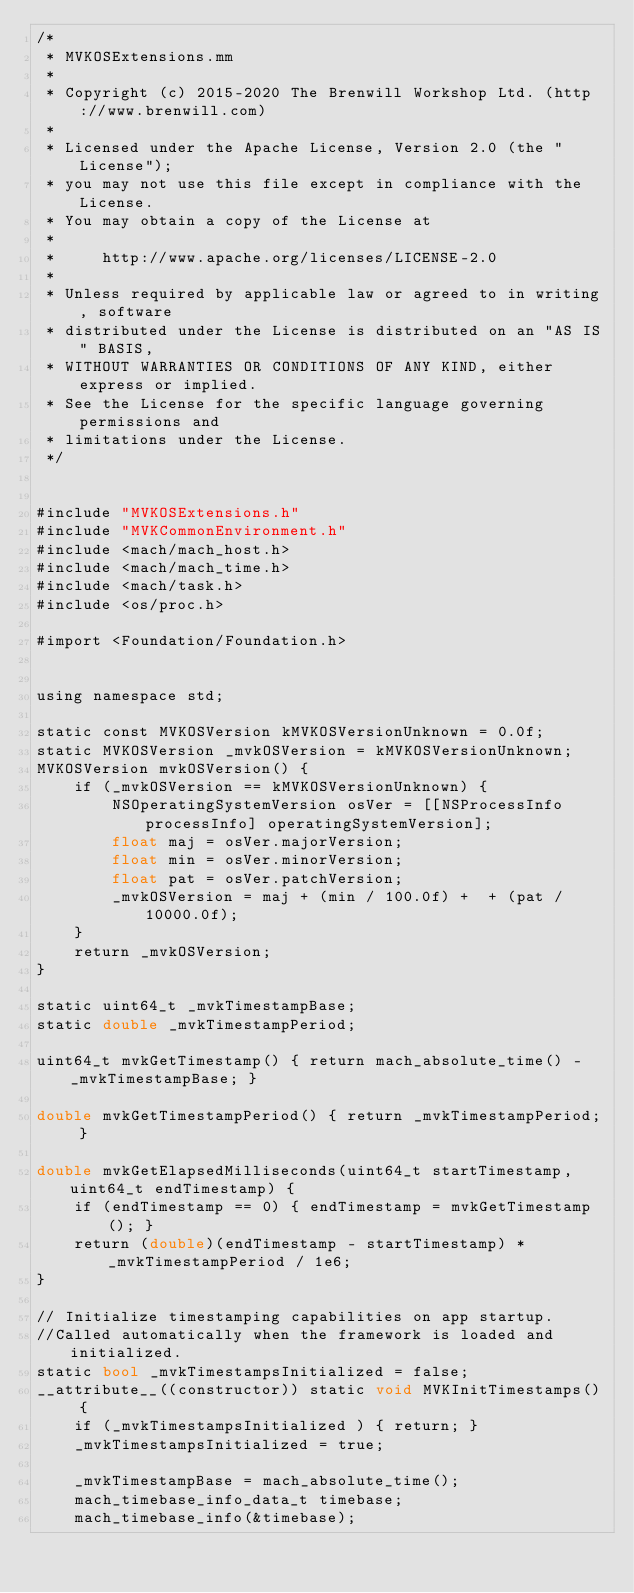<code> <loc_0><loc_0><loc_500><loc_500><_ObjectiveC_>/*
 * MVKOSExtensions.mm
 *
 * Copyright (c) 2015-2020 The Brenwill Workshop Ltd. (http://www.brenwill.com)
 *
 * Licensed under the Apache License, Version 2.0 (the "License");
 * you may not use this file except in compliance with the License.
 * You may obtain a copy of the License at
 * 
 *     http://www.apache.org/licenses/LICENSE-2.0
 * 
 * Unless required by applicable law or agreed to in writing, software
 * distributed under the License is distributed on an "AS IS" BASIS,
 * WITHOUT WARRANTIES OR CONDITIONS OF ANY KIND, either express or implied.
 * See the License for the specific language governing permissions and
 * limitations under the License.
 */


#include "MVKOSExtensions.h"
#include "MVKCommonEnvironment.h"
#include <mach/mach_host.h>
#include <mach/mach_time.h>
#include <mach/task.h>
#include <os/proc.h>

#import <Foundation/Foundation.h>


using namespace std;

static const MVKOSVersion kMVKOSVersionUnknown = 0.0f;
static MVKOSVersion _mvkOSVersion = kMVKOSVersionUnknown;
MVKOSVersion mvkOSVersion() {
    if (_mvkOSVersion == kMVKOSVersionUnknown) {
        NSOperatingSystemVersion osVer = [[NSProcessInfo processInfo] operatingSystemVersion];
        float maj = osVer.majorVersion;
        float min = osVer.minorVersion;
        float pat = osVer.patchVersion;
        _mvkOSVersion = maj + (min / 100.0f) +  + (pat / 10000.0f);
    }
    return _mvkOSVersion;
}

static uint64_t _mvkTimestampBase;
static double _mvkTimestampPeriod;

uint64_t mvkGetTimestamp() { return mach_absolute_time() - _mvkTimestampBase; }

double mvkGetTimestampPeriod() { return _mvkTimestampPeriod; }

double mvkGetElapsedMilliseconds(uint64_t startTimestamp, uint64_t endTimestamp) {
	if (endTimestamp == 0) { endTimestamp = mvkGetTimestamp(); }
	return (double)(endTimestamp - startTimestamp) * _mvkTimestampPeriod / 1e6;
}

// Initialize timestamping capabilities on app startup.
//Called automatically when the framework is loaded and initialized.
static bool _mvkTimestampsInitialized = false;
__attribute__((constructor)) static void MVKInitTimestamps() {
	if (_mvkTimestampsInitialized ) { return; }
	_mvkTimestampsInitialized = true;

	_mvkTimestampBase = mach_absolute_time();
	mach_timebase_info_data_t timebase;
	mach_timebase_info(&timebase);</code> 